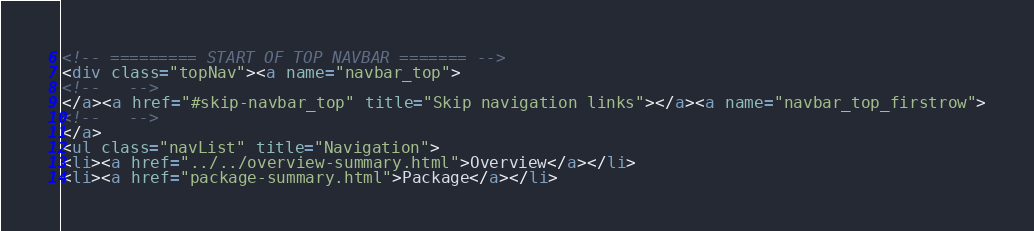Convert code to text. <code><loc_0><loc_0><loc_500><loc_500><_HTML_><!-- ========= START OF TOP NAVBAR ======= -->
<div class="topNav"><a name="navbar_top">
<!--   -->
</a><a href="#skip-navbar_top" title="Skip navigation links"></a><a name="navbar_top_firstrow">
<!--   -->
</a>
<ul class="navList" title="Navigation">
<li><a href="../../overview-summary.html">Overview</a></li>
<li><a href="package-summary.html">Package</a></li></code> 